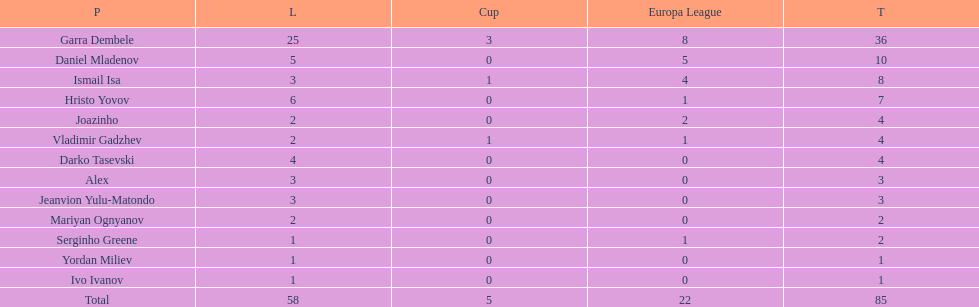What is the sum of the cup total and the europa league total? 27. 